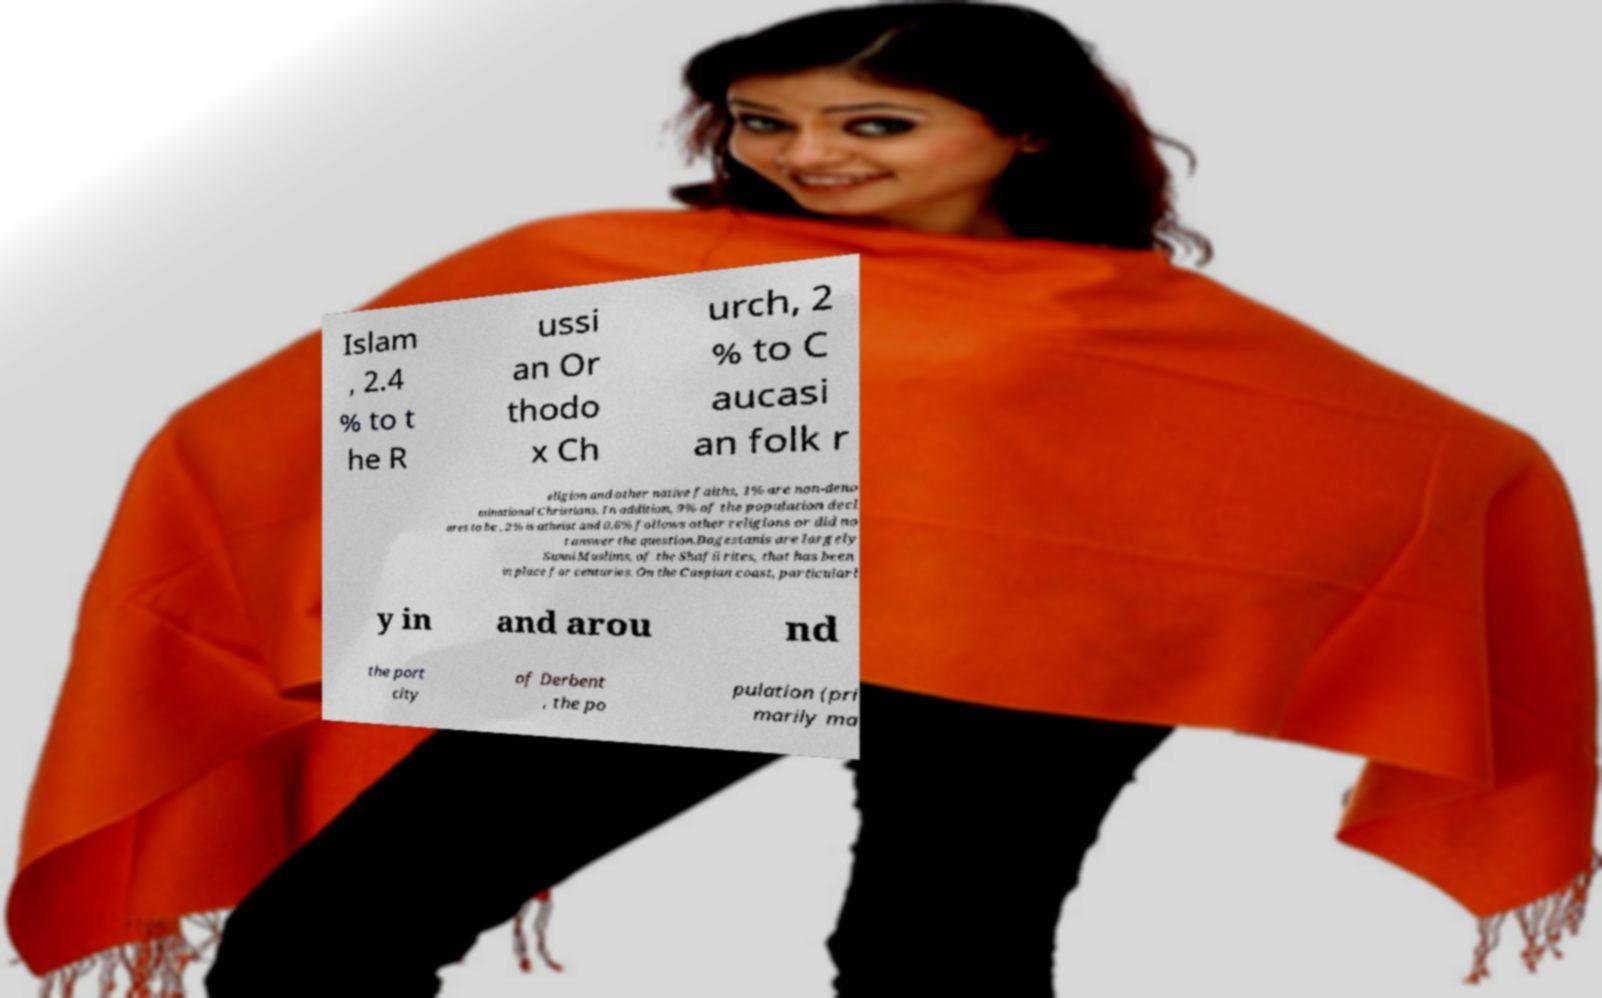For documentation purposes, I need the text within this image transcribed. Could you provide that? Islam , 2.4 % to t he R ussi an Or thodo x Ch urch, 2 % to C aucasi an folk r eligion and other native faiths, 1% are non-deno minational Christians. In addition, 9% of the population decl ares to be , 2% is atheist and 0.6% follows other religions or did no t answer the question.Dagestanis are largely Sunni Muslims, of the Shafii rites, that has been in place for centuries. On the Caspian coast, particularl y in and arou nd the port city of Derbent , the po pulation (pri marily ma 